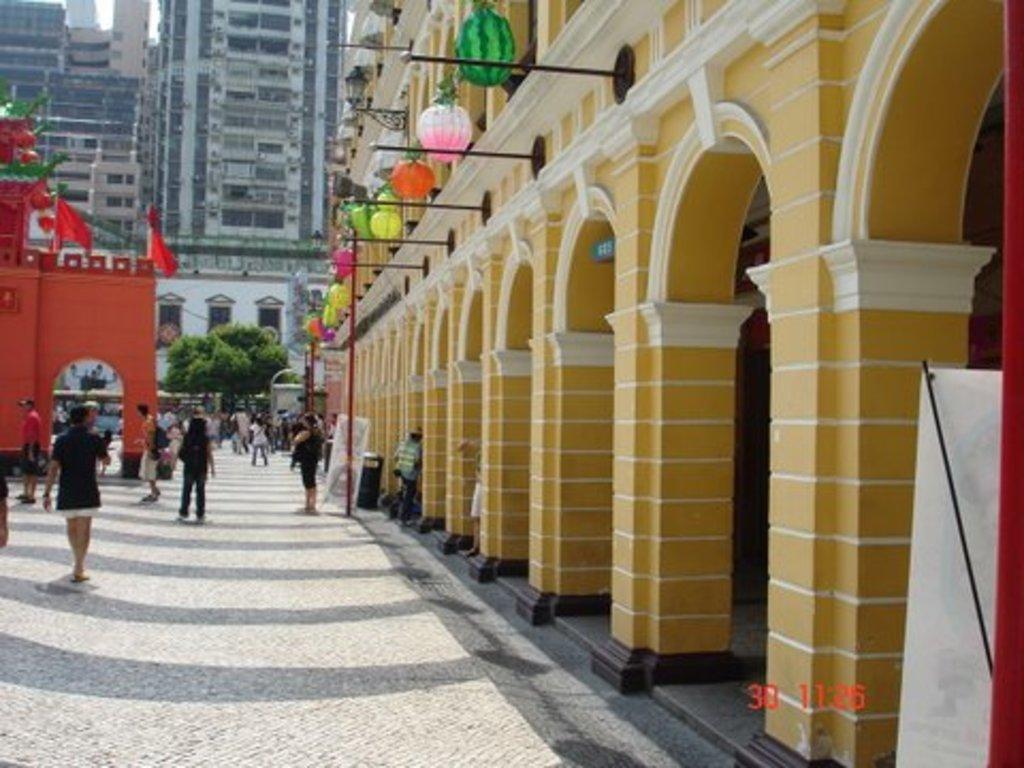Could you give a brief overview of what you see in this image? In the center of the image we can see buildings, lights, poles, tree, windows, flags, arch, some persons, boards. At the bottom of the image we can see road, board and some text. At the top left corner we can see the sky. 